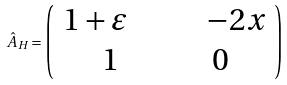<formula> <loc_0><loc_0><loc_500><loc_500>\hat { A } _ { H } = \left ( \begin{array} { c c } 1 + \varepsilon \quad & \quad - 2 x \\ 1 & 0 \end{array} \right )</formula> 